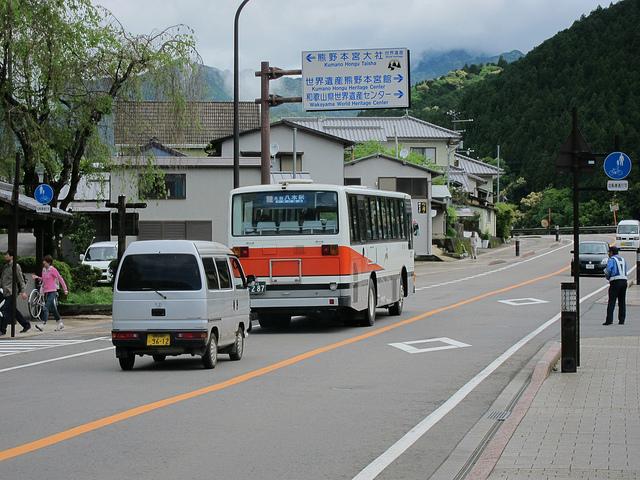What color is the unbroken line?
Write a very short answer. Yellow. Is the bus moving toward or away from the photographer?
Be succinct. Away. How many diamonds are on the road?
Keep it brief. 2. Are there vehicles going in both directions?
Be succinct. Yes. What does it say on the white sign?
Keep it brief. Foreign language. How many buses are here?
Be succinct. 1. Where is the bus going?
Give a very brief answer. Downtown. What kind of vehicles are shown?
Answer briefly. Buses. Is this city in the United States?
Give a very brief answer. No. 